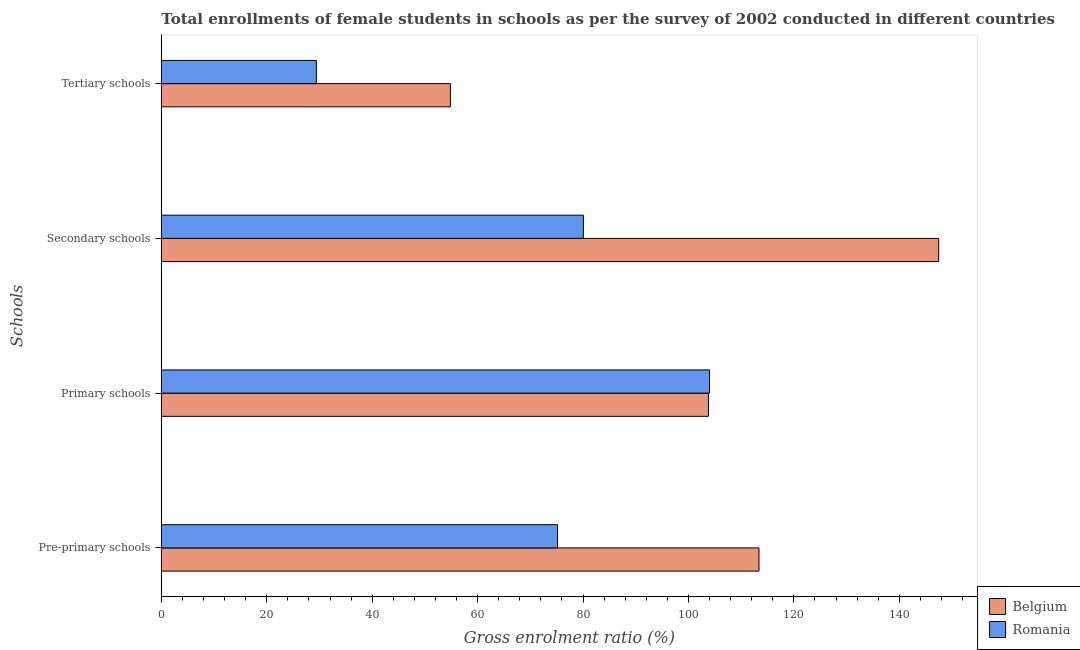How many different coloured bars are there?
Provide a short and direct response. 2. Are the number of bars per tick equal to the number of legend labels?
Offer a very short reply. Yes. What is the label of the 4th group of bars from the top?
Your response must be concise. Pre-primary schools. What is the gross enrolment ratio(female) in secondary schools in Belgium?
Your answer should be compact. 147.48. Across all countries, what is the maximum gross enrolment ratio(female) in primary schools?
Make the answer very short. 103.99. Across all countries, what is the minimum gross enrolment ratio(female) in pre-primary schools?
Your response must be concise. 75.16. In which country was the gross enrolment ratio(female) in tertiary schools maximum?
Offer a very short reply. Belgium. In which country was the gross enrolment ratio(female) in pre-primary schools minimum?
Make the answer very short. Romania. What is the total gross enrolment ratio(female) in secondary schools in the graph?
Your answer should be very brief. 227.55. What is the difference between the gross enrolment ratio(female) in pre-primary schools in Romania and that in Belgium?
Offer a terse response. -38.22. What is the difference between the gross enrolment ratio(female) in secondary schools in Romania and the gross enrolment ratio(female) in pre-primary schools in Belgium?
Give a very brief answer. -33.31. What is the average gross enrolment ratio(female) in primary schools per country?
Provide a succinct answer. 103.89. What is the difference between the gross enrolment ratio(female) in primary schools and gross enrolment ratio(female) in pre-primary schools in Romania?
Provide a short and direct response. 28.83. What is the ratio of the gross enrolment ratio(female) in pre-primary schools in Romania to that in Belgium?
Provide a short and direct response. 0.66. Is the gross enrolment ratio(female) in pre-primary schools in Romania less than that in Belgium?
Give a very brief answer. Yes. Is the difference between the gross enrolment ratio(female) in tertiary schools in Romania and Belgium greater than the difference between the gross enrolment ratio(female) in secondary schools in Romania and Belgium?
Give a very brief answer. Yes. What is the difference between the highest and the second highest gross enrolment ratio(female) in primary schools?
Offer a terse response. 0.2. What is the difference between the highest and the lowest gross enrolment ratio(female) in secondary schools?
Provide a succinct answer. 67.41. What does the 1st bar from the top in Tertiary schools represents?
Your answer should be very brief. Romania. How many countries are there in the graph?
Ensure brevity in your answer.  2. Are the values on the major ticks of X-axis written in scientific E-notation?
Make the answer very short. No. Does the graph contain grids?
Offer a very short reply. No. How are the legend labels stacked?
Offer a very short reply. Vertical. What is the title of the graph?
Ensure brevity in your answer.  Total enrollments of female students in schools as per the survey of 2002 conducted in different countries. What is the label or title of the Y-axis?
Offer a very short reply. Schools. What is the Gross enrolment ratio (%) of Belgium in Pre-primary schools?
Provide a short and direct response. 113.38. What is the Gross enrolment ratio (%) in Romania in Pre-primary schools?
Your answer should be very brief. 75.16. What is the Gross enrolment ratio (%) of Belgium in Primary schools?
Provide a succinct answer. 103.79. What is the Gross enrolment ratio (%) of Romania in Primary schools?
Offer a very short reply. 103.99. What is the Gross enrolment ratio (%) in Belgium in Secondary schools?
Your answer should be compact. 147.48. What is the Gross enrolment ratio (%) in Romania in Secondary schools?
Make the answer very short. 80.07. What is the Gross enrolment ratio (%) in Belgium in Tertiary schools?
Offer a very short reply. 54.84. What is the Gross enrolment ratio (%) in Romania in Tertiary schools?
Keep it short and to the point. 29.42. Across all Schools, what is the maximum Gross enrolment ratio (%) in Belgium?
Provide a succinct answer. 147.48. Across all Schools, what is the maximum Gross enrolment ratio (%) of Romania?
Make the answer very short. 103.99. Across all Schools, what is the minimum Gross enrolment ratio (%) of Belgium?
Your answer should be very brief. 54.84. Across all Schools, what is the minimum Gross enrolment ratio (%) of Romania?
Your answer should be compact. 29.42. What is the total Gross enrolment ratio (%) in Belgium in the graph?
Your response must be concise. 419.49. What is the total Gross enrolment ratio (%) in Romania in the graph?
Provide a succinct answer. 288.64. What is the difference between the Gross enrolment ratio (%) of Belgium in Pre-primary schools and that in Primary schools?
Offer a very short reply. 9.59. What is the difference between the Gross enrolment ratio (%) in Romania in Pre-primary schools and that in Primary schools?
Offer a terse response. -28.83. What is the difference between the Gross enrolment ratio (%) in Belgium in Pre-primary schools and that in Secondary schools?
Offer a very short reply. -34.1. What is the difference between the Gross enrolment ratio (%) in Romania in Pre-primary schools and that in Secondary schools?
Give a very brief answer. -4.91. What is the difference between the Gross enrolment ratio (%) in Belgium in Pre-primary schools and that in Tertiary schools?
Keep it short and to the point. 58.54. What is the difference between the Gross enrolment ratio (%) of Romania in Pre-primary schools and that in Tertiary schools?
Your response must be concise. 45.74. What is the difference between the Gross enrolment ratio (%) of Belgium in Primary schools and that in Secondary schools?
Your answer should be compact. -43.69. What is the difference between the Gross enrolment ratio (%) in Romania in Primary schools and that in Secondary schools?
Give a very brief answer. 23.92. What is the difference between the Gross enrolment ratio (%) of Belgium in Primary schools and that in Tertiary schools?
Provide a succinct answer. 48.96. What is the difference between the Gross enrolment ratio (%) of Romania in Primary schools and that in Tertiary schools?
Provide a succinct answer. 74.58. What is the difference between the Gross enrolment ratio (%) of Belgium in Secondary schools and that in Tertiary schools?
Your response must be concise. 92.64. What is the difference between the Gross enrolment ratio (%) in Romania in Secondary schools and that in Tertiary schools?
Offer a very short reply. 50.66. What is the difference between the Gross enrolment ratio (%) in Belgium in Pre-primary schools and the Gross enrolment ratio (%) in Romania in Primary schools?
Your answer should be compact. 9.39. What is the difference between the Gross enrolment ratio (%) of Belgium in Pre-primary schools and the Gross enrolment ratio (%) of Romania in Secondary schools?
Make the answer very short. 33.31. What is the difference between the Gross enrolment ratio (%) in Belgium in Pre-primary schools and the Gross enrolment ratio (%) in Romania in Tertiary schools?
Your answer should be compact. 83.96. What is the difference between the Gross enrolment ratio (%) of Belgium in Primary schools and the Gross enrolment ratio (%) of Romania in Secondary schools?
Give a very brief answer. 23.72. What is the difference between the Gross enrolment ratio (%) in Belgium in Primary schools and the Gross enrolment ratio (%) in Romania in Tertiary schools?
Provide a succinct answer. 74.38. What is the difference between the Gross enrolment ratio (%) of Belgium in Secondary schools and the Gross enrolment ratio (%) of Romania in Tertiary schools?
Your answer should be very brief. 118.06. What is the average Gross enrolment ratio (%) of Belgium per Schools?
Your answer should be very brief. 104.87. What is the average Gross enrolment ratio (%) in Romania per Schools?
Ensure brevity in your answer.  72.16. What is the difference between the Gross enrolment ratio (%) in Belgium and Gross enrolment ratio (%) in Romania in Pre-primary schools?
Your answer should be compact. 38.22. What is the difference between the Gross enrolment ratio (%) of Belgium and Gross enrolment ratio (%) of Romania in Primary schools?
Keep it short and to the point. -0.2. What is the difference between the Gross enrolment ratio (%) in Belgium and Gross enrolment ratio (%) in Romania in Secondary schools?
Keep it short and to the point. 67.41. What is the difference between the Gross enrolment ratio (%) of Belgium and Gross enrolment ratio (%) of Romania in Tertiary schools?
Offer a terse response. 25.42. What is the ratio of the Gross enrolment ratio (%) in Belgium in Pre-primary schools to that in Primary schools?
Make the answer very short. 1.09. What is the ratio of the Gross enrolment ratio (%) of Romania in Pre-primary schools to that in Primary schools?
Keep it short and to the point. 0.72. What is the ratio of the Gross enrolment ratio (%) in Belgium in Pre-primary schools to that in Secondary schools?
Provide a succinct answer. 0.77. What is the ratio of the Gross enrolment ratio (%) in Romania in Pre-primary schools to that in Secondary schools?
Offer a very short reply. 0.94. What is the ratio of the Gross enrolment ratio (%) of Belgium in Pre-primary schools to that in Tertiary schools?
Ensure brevity in your answer.  2.07. What is the ratio of the Gross enrolment ratio (%) of Romania in Pre-primary schools to that in Tertiary schools?
Give a very brief answer. 2.56. What is the ratio of the Gross enrolment ratio (%) of Belgium in Primary schools to that in Secondary schools?
Ensure brevity in your answer.  0.7. What is the ratio of the Gross enrolment ratio (%) in Romania in Primary schools to that in Secondary schools?
Give a very brief answer. 1.3. What is the ratio of the Gross enrolment ratio (%) in Belgium in Primary schools to that in Tertiary schools?
Offer a terse response. 1.89. What is the ratio of the Gross enrolment ratio (%) of Romania in Primary schools to that in Tertiary schools?
Offer a very short reply. 3.54. What is the ratio of the Gross enrolment ratio (%) of Belgium in Secondary schools to that in Tertiary schools?
Give a very brief answer. 2.69. What is the ratio of the Gross enrolment ratio (%) in Romania in Secondary schools to that in Tertiary schools?
Ensure brevity in your answer.  2.72. What is the difference between the highest and the second highest Gross enrolment ratio (%) in Belgium?
Your answer should be very brief. 34.1. What is the difference between the highest and the second highest Gross enrolment ratio (%) of Romania?
Provide a succinct answer. 23.92. What is the difference between the highest and the lowest Gross enrolment ratio (%) of Belgium?
Provide a succinct answer. 92.64. What is the difference between the highest and the lowest Gross enrolment ratio (%) in Romania?
Offer a very short reply. 74.58. 